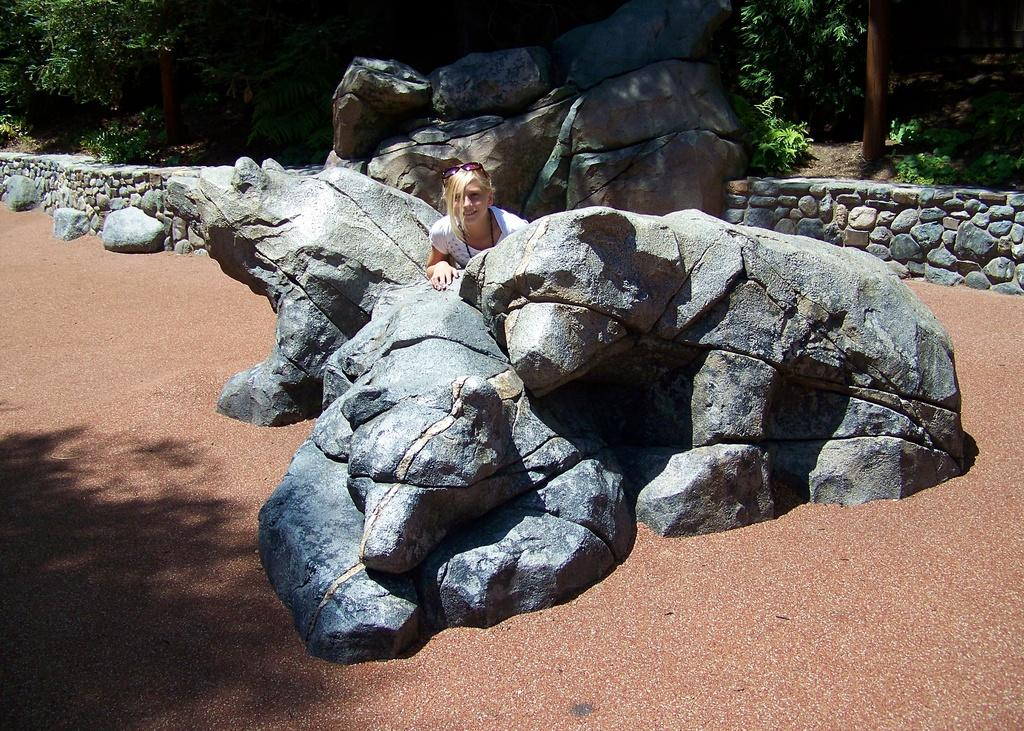Who is present in the image? There is a woman in the image. What is the woman doing or standing near in the image? The woman is behind sculptures in the image. What type of natural elements can be seen in the image? There are rocks, trees, and ground visible in the image. What man-made structures are present in the image? There is a wall in the image. What type of approval does the woman need to obtain from the fireman in the image? There is no fireman present in the image, and therefore no approval is needed. 